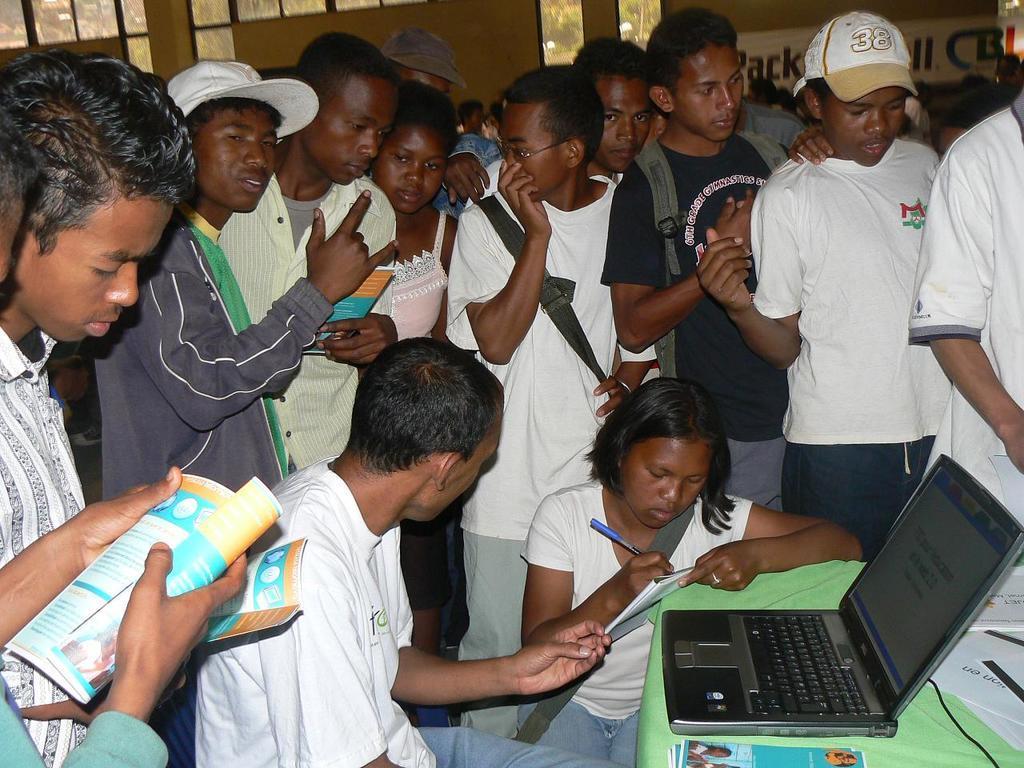Describe this image in one or two sentences. In this image we can see a group of persons and among them few people are holding objects and a person is writing. In the bottom right we can see the objects on a table. Behind the persons we can see a wall with glass. Through the glass we can see the trees. 